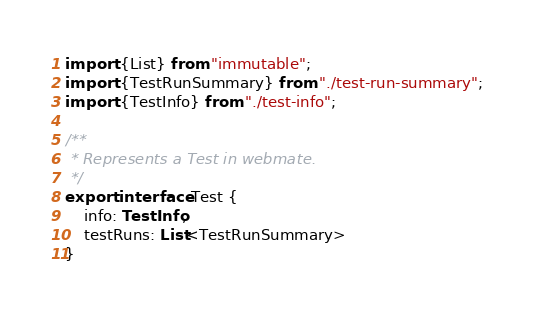Convert code to text. <code><loc_0><loc_0><loc_500><loc_500><_TypeScript_>import {List} from "immutable";
import {TestRunSummary} from "./test-run-summary";
import {TestInfo} from "./test-info";

/**
 * Represents a Test in webmate.
 */
export interface Test {
    info: TestInfo,
    testRuns: List<TestRunSummary>
}
</code> 